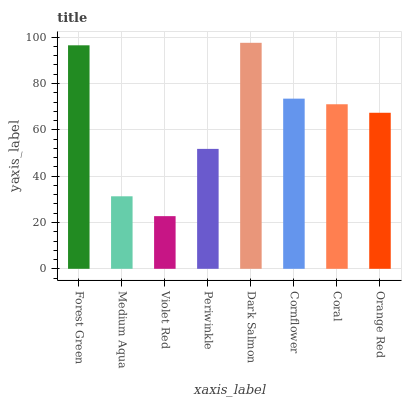Is Violet Red the minimum?
Answer yes or no. Yes. Is Dark Salmon the maximum?
Answer yes or no. Yes. Is Medium Aqua the minimum?
Answer yes or no. No. Is Medium Aqua the maximum?
Answer yes or no. No. Is Forest Green greater than Medium Aqua?
Answer yes or no. Yes. Is Medium Aqua less than Forest Green?
Answer yes or no. Yes. Is Medium Aqua greater than Forest Green?
Answer yes or no. No. Is Forest Green less than Medium Aqua?
Answer yes or no. No. Is Coral the high median?
Answer yes or no. Yes. Is Orange Red the low median?
Answer yes or no. Yes. Is Dark Salmon the high median?
Answer yes or no. No. Is Forest Green the low median?
Answer yes or no. No. 